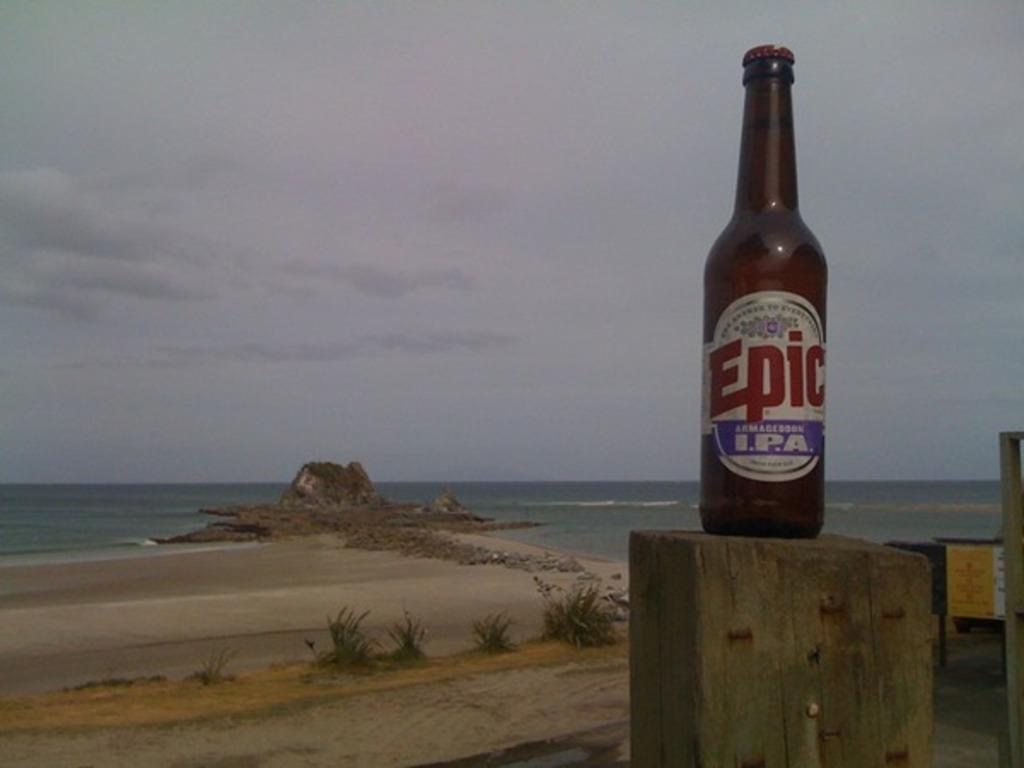<image>
Render a clear and concise summary of the photo. A bottle of Epic brand IPA beer sitting on a post. 